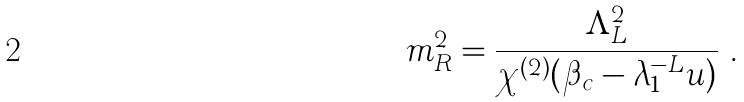Convert formula to latex. <formula><loc_0><loc_0><loc_500><loc_500>m _ { R } ^ { 2 } = \frac { \Lambda _ { L } ^ { 2 } } { \chi ^ { ( 2 ) } ( \beta _ { c } - \lambda _ { 1 } ^ { - L } u ) } \ .</formula> 